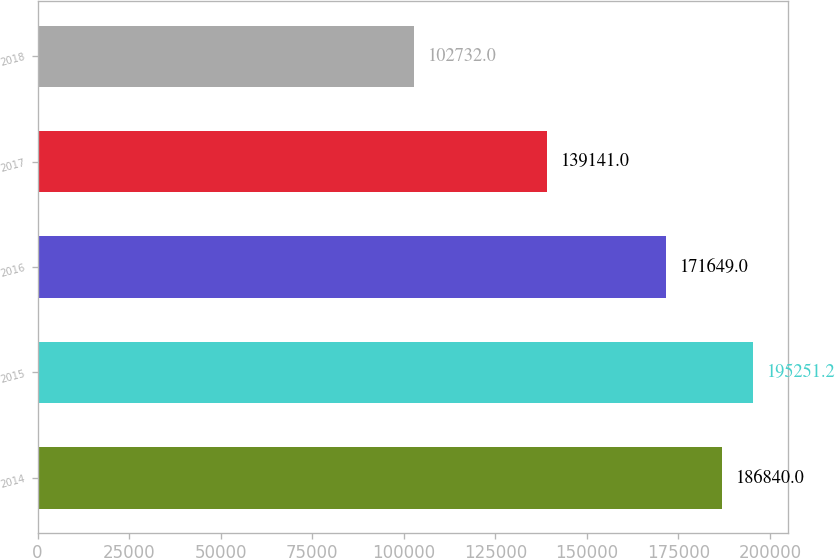Convert chart to OTSL. <chart><loc_0><loc_0><loc_500><loc_500><bar_chart><fcel>2014<fcel>2015<fcel>2016<fcel>2017<fcel>2018<nl><fcel>186840<fcel>195251<fcel>171649<fcel>139141<fcel>102732<nl></chart> 